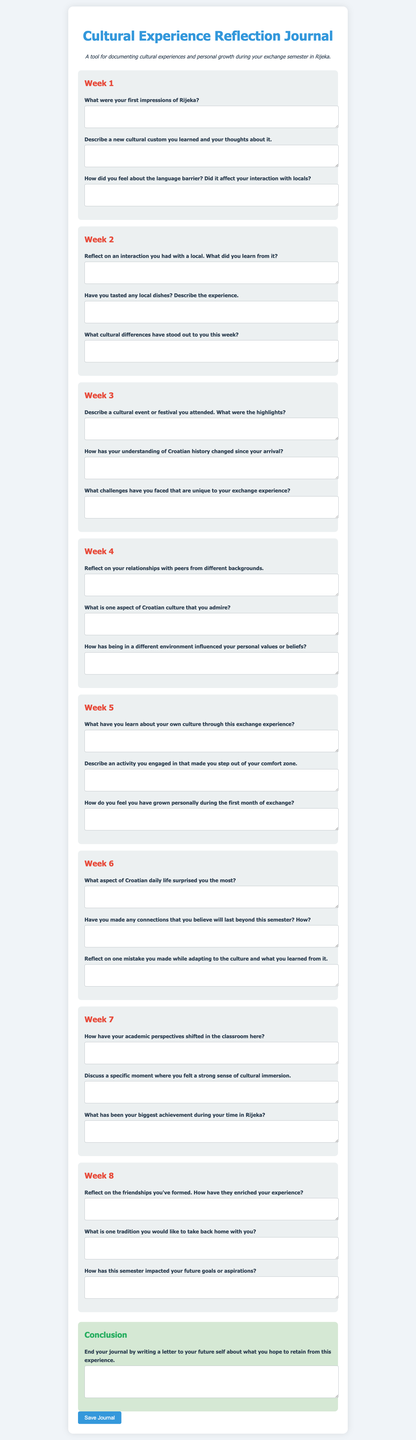What is the title of the journal? The title is mentioned at the top of the document within the main heading.
Answer: Cultural Experience Reflection Journal How many weeks are covered in the reflection journal? The document includes a section for each week, and they are numbered from 1 to 8.
Answer: 8 What is the color of the button used to save the journal? The button's background color is specified in the style section of the document.
Answer: Blue What cultural differences were asked to be reflected on in Week 2? Week 2 has a specific question about cultural differences that stood out during that week.
Answer: Cultural differences What is one aspect of Croatian culture that the document prompts to admire in Week 4? The question in Week 4 specifically asks about one aspect of Croatian culture for admiration.
Answer: One aspect of Croatian culture What type of letter is suggested to end the journal? The conclusion section of the document suggests writing a letter directed toward one's future self.
Answer: Letter to future self What color is the background of the conclusion section? The background color of the conclusion section is stated in the style definitions.
Answer: Light green Which week focuses on reflecting on academic perspectives? The week focusing on this theme is specified within a defined section of the journal.
Answer: Week 7 